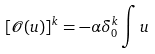<formula> <loc_0><loc_0><loc_500><loc_500>[ { \mathcal { O } } ( u ) ] ^ { k } = - \alpha \delta ^ { k } _ { 0 } \int u</formula> 